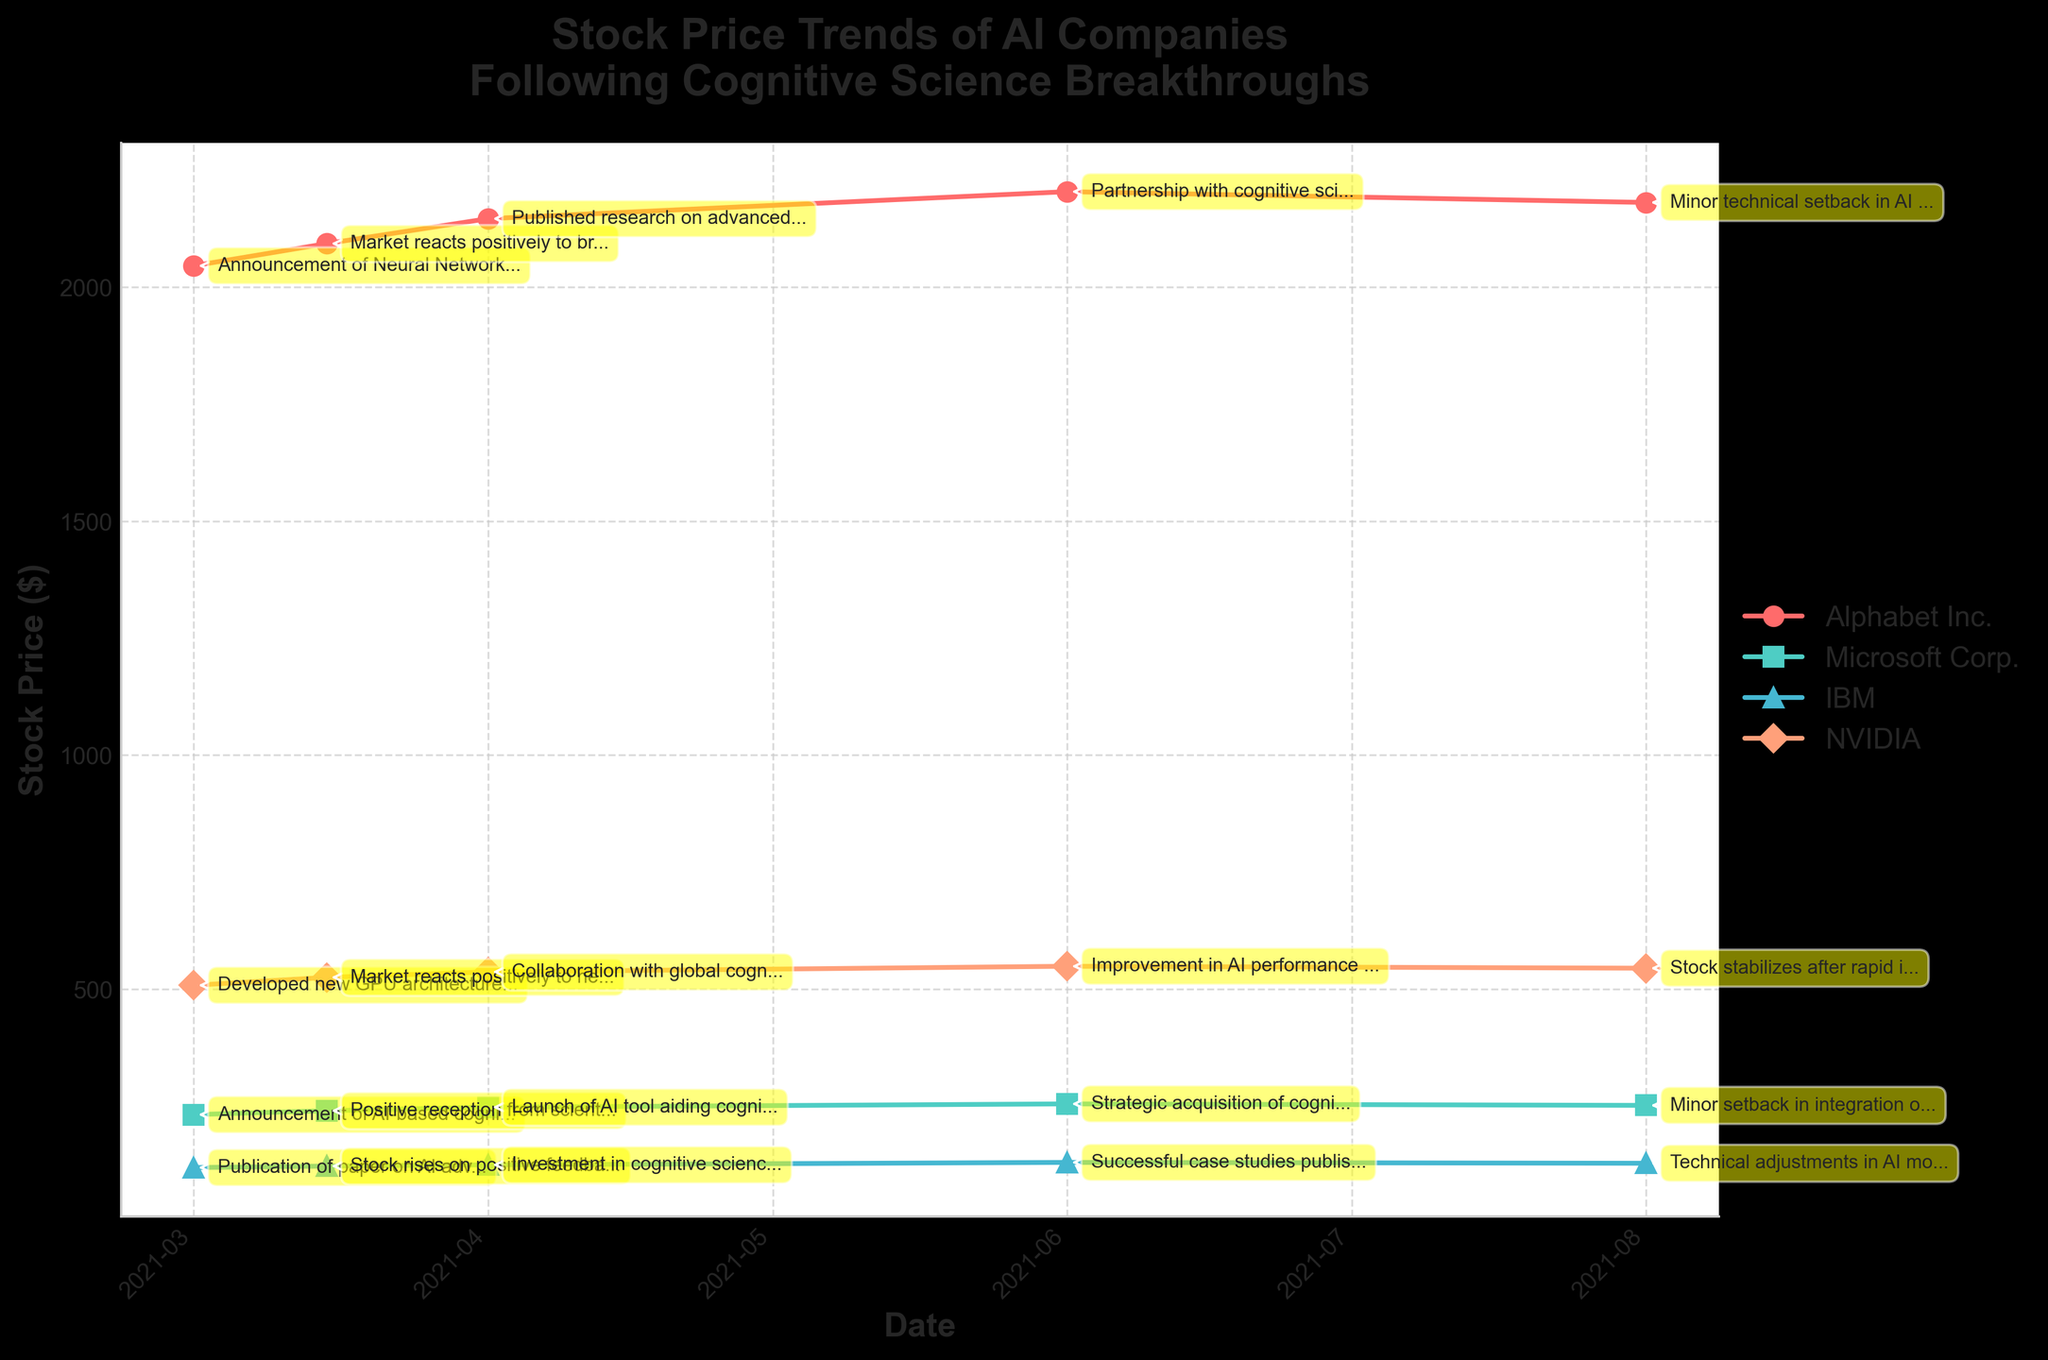What is the title of this figure? The title of the figure is directly visible at the top and describes the overall context of the figure. It reads: 'Stock Price Trends of AI Companies Following Cognitive Science Breakthroughs'.
Answer: Stock Price Trends of AI Companies Following Cognitive Science Breakthroughs Which company experienced the highest stock price on August 1, 2021? To find the highest stock price, look at the points for August 1, 2021, and compare the stock prices of the four companies. NVIDIA's stock price is the highest, at $545.10.
Answer: NVIDIA What is the overall trend for Alphabet Inc.'s stock price from March 1, 2021, to August 1, 2021? Observing the plot line for Alphabet Inc., the stock price generally increases, with a rise from $2045.28 on March 1, 2021, to $2203.60 on June 1, 2021, and then a slight decrease to $2180.50 by August 1, 2021.
Answer: Increasing trend with a slight decrease at the end Which company saw the largest percent increase in stock price from March 1, 2021, to June 1, 2021? To determine the largest percent increase, calculate the percent change for each company over this period: Alphabet Inc., Microsoft Corp., IBM, and NVIDIA. 
- Alphabet Inc.: ((2203.60 - 2045.28) / 2045.28) * 100 = 7.75%
- Microsoft Corp.: ((255.31 - 232.38) / 232.38) * 100 = 9.86%
- IBM: ((130.33 - 119.32) / 119.32) * 100 = 9.23%
- NVIDIA: ((549.27 - 508.64) / 508.64) * 100 = 7.99%
Microsoft Corp. has the highest percent increase.
Answer: Microsoft Corp Which event on the plot is associated with the highest spike in stock price for IBM? Identify the points on IBM's line and check the prices at each event annotation. The highest spike in stock price for IBM occurred on June 1, 2021, at $130.33, associated with the 'Successful case studies published' event.
Answer: Successful case studies published How did the market react to NVIDIA's new GPU architecture for cognitive AI research announced on March 1, 2021? Refer to the plot line for NVIDIA. On March 1, 2021, the stock price is $508.64, and then it increases to $525.48 on March 15, 2021, showing a positive market reaction.
Answer: Positively Compare the stock price trend of Alphabet Inc. and Microsoft Corp. following their stock setbacks in August 2021. Observing the plot, both companies experience setbacks. Alphabet Inc.'s price decreases slightly from $2203.60 on June 1, 2021, to $2180.50 on August 1, 2021. Microsoft's price also decreases slightly from $255.31 on June 1, 2021, to $252.10 on August 1, 2021. Both trends show minor decreases.
Answer: Both decreased slightly What is the difference in the stock price of IBM between April 1, 2021, and June 1, 2021? Find the stock prices for IBM on both dates and subtract the earlier price from the later one: $130.33 (June 1, 2021) - $125.12 (April 1, 2021) = $5.21.
Answer: $5.21 